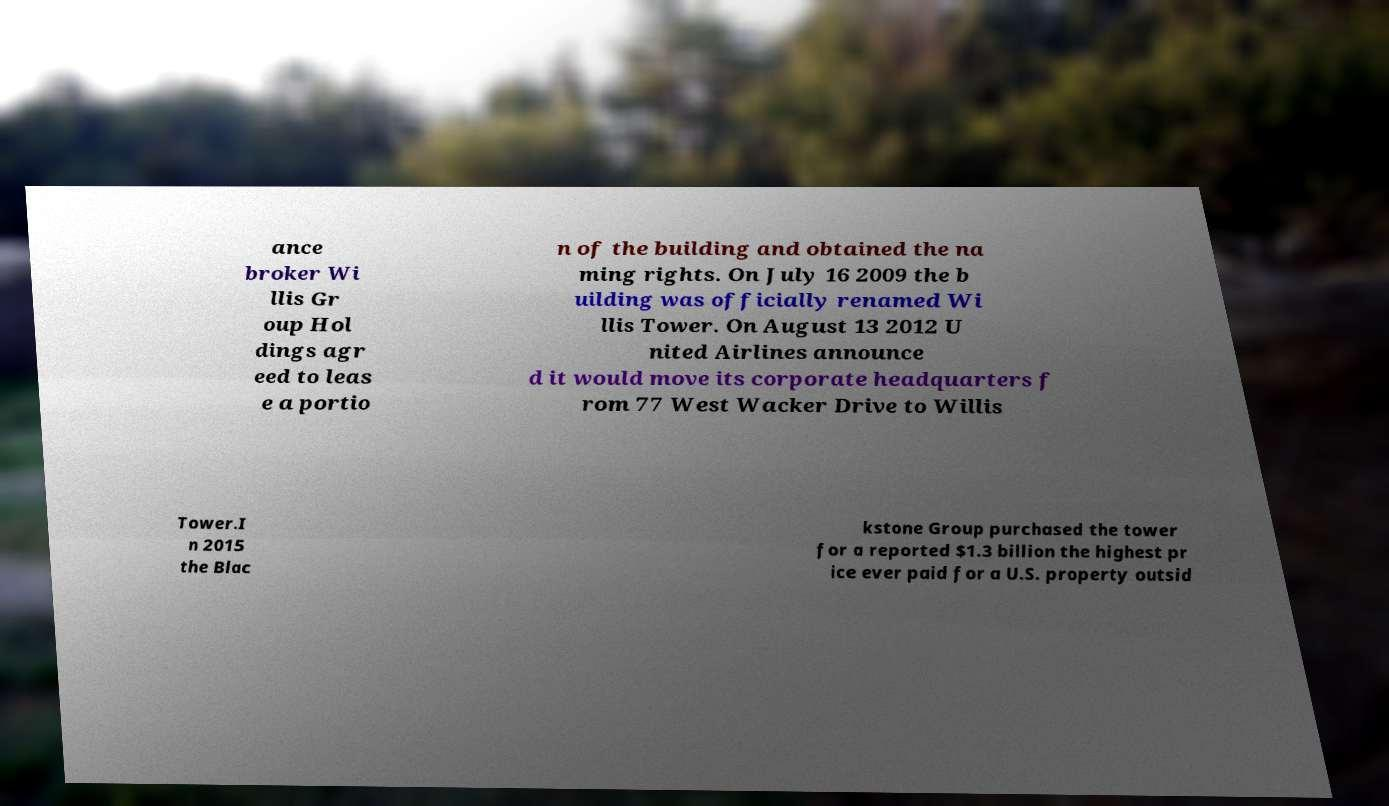Please identify and transcribe the text found in this image. ance broker Wi llis Gr oup Hol dings agr eed to leas e a portio n of the building and obtained the na ming rights. On July 16 2009 the b uilding was officially renamed Wi llis Tower. On August 13 2012 U nited Airlines announce d it would move its corporate headquarters f rom 77 West Wacker Drive to Willis Tower.I n 2015 the Blac kstone Group purchased the tower for a reported $1.3 billion the highest pr ice ever paid for a U.S. property outsid 